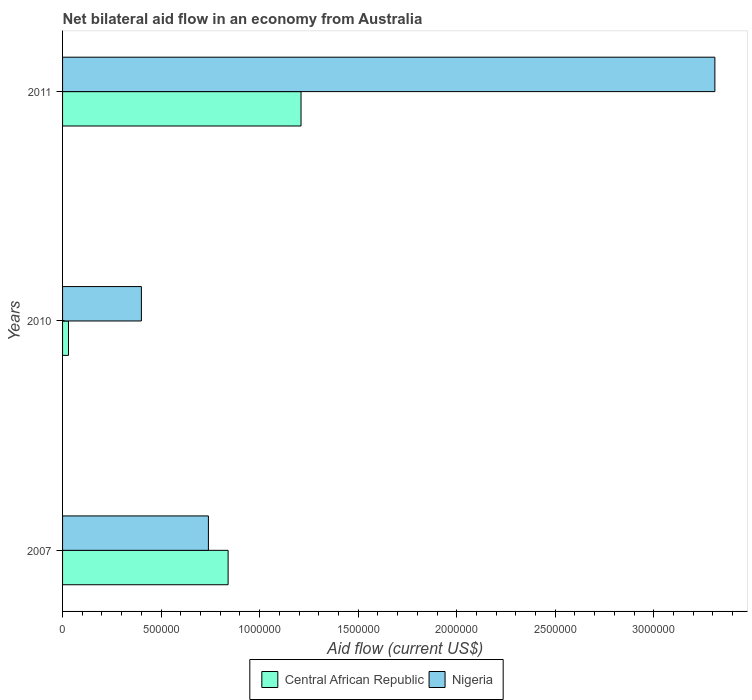How many groups of bars are there?
Your answer should be compact. 3. How many bars are there on the 1st tick from the top?
Offer a very short reply. 2. In how many cases, is the number of bars for a given year not equal to the number of legend labels?
Your answer should be very brief. 0. What is the net bilateral aid flow in Central African Republic in 2011?
Ensure brevity in your answer.  1.21e+06. Across all years, what is the maximum net bilateral aid flow in Nigeria?
Provide a succinct answer. 3.31e+06. Across all years, what is the minimum net bilateral aid flow in Nigeria?
Your answer should be very brief. 4.00e+05. What is the total net bilateral aid flow in Central African Republic in the graph?
Offer a terse response. 2.08e+06. What is the difference between the net bilateral aid flow in Central African Republic in 2007 and that in 2010?
Provide a succinct answer. 8.10e+05. What is the difference between the net bilateral aid flow in Central African Republic in 2010 and the net bilateral aid flow in Nigeria in 2011?
Provide a short and direct response. -3.28e+06. What is the average net bilateral aid flow in Nigeria per year?
Keep it short and to the point. 1.48e+06. In the year 2011, what is the difference between the net bilateral aid flow in Nigeria and net bilateral aid flow in Central African Republic?
Provide a short and direct response. 2.10e+06. In how many years, is the net bilateral aid flow in Central African Republic greater than 2700000 US$?
Ensure brevity in your answer.  0. What is the ratio of the net bilateral aid flow in Nigeria in 2010 to that in 2011?
Your response must be concise. 0.12. Is the net bilateral aid flow in Central African Republic in 2010 less than that in 2011?
Give a very brief answer. Yes. What is the difference between the highest and the second highest net bilateral aid flow in Central African Republic?
Your answer should be very brief. 3.70e+05. What is the difference between the highest and the lowest net bilateral aid flow in Central African Republic?
Provide a succinct answer. 1.18e+06. Is the sum of the net bilateral aid flow in Nigeria in 2010 and 2011 greater than the maximum net bilateral aid flow in Central African Republic across all years?
Provide a short and direct response. Yes. What does the 1st bar from the top in 2007 represents?
Offer a very short reply. Nigeria. What does the 1st bar from the bottom in 2011 represents?
Offer a very short reply. Central African Republic. Are all the bars in the graph horizontal?
Ensure brevity in your answer.  Yes. What is the difference between two consecutive major ticks on the X-axis?
Your answer should be compact. 5.00e+05. Does the graph contain any zero values?
Provide a short and direct response. No. Does the graph contain grids?
Your response must be concise. No. How are the legend labels stacked?
Offer a terse response. Horizontal. What is the title of the graph?
Your response must be concise. Net bilateral aid flow in an economy from Australia. What is the Aid flow (current US$) of Central African Republic in 2007?
Offer a terse response. 8.40e+05. What is the Aid flow (current US$) in Nigeria in 2007?
Ensure brevity in your answer.  7.40e+05. What is the Aid flow (current US$) of Nigeria in 2010?
Your response must be concise. 4.00e+05. What is the Aid flow (current US$) in Central African Republic in 2011?
Offer a very short reply. 1.21e+06. What is the Aid flow (current US$) in Nigeria in 2011?
Make the answer very short. 3.31e+06. Across all years, what is the maximum Aid flow (current US$) of Central African Republic?
Your answer should be very brief. 1.21e+06. Across all years, what is the maximum Aid flow (current US$) of Nigeria?
Provide a short and direct response. 3.31e+06. Across all years, what is the minimum Aid flow (current US$) in Central African Republic?
Your response must be concise. 3.00e+04. What is the total Aid flow (current US$) in Central African Republic in the graph?
Give a very brief answer. 2.08e+06. What is the total Aid flow (current US$) in Nigeria in the graph?
Provide a succinct answer. 4.45e+06. What is the difference between the Aid flow (current US$) of Central African Republic in 2007 and that in 2010?
Provide a short and direct response. 8.10e+05. What is the difference between the Aid flow (current US$) of Central African Republic in 2007 and that in 2011?
Provide a succinct answer. -3.70e+05. What is the difference between the Aid flow (current US$) of Nigeria in 2007 and that in 2011?
Provide a short and direct response. -2.57e+06. What is the difference between the Aid flow (current US$) in Central African Republic in 2010 and that in 2011?
Your answer should be very brief. -1.18e+06. What is the difference between the Aid flow (current US$) in Nigeria in 2010 and that in 2011?
Your answer should be compact. -2.91e+06. What is the difference between the Aid flow (current US$) of Central African Republic in 2007 and the Aid flow (current US$) of Nigeria in 2011?
Make the answer very short. -2.47e+06. What is the difference between the Aid flow (current US$) of Central African Republic in 2010 and the Aid flow (current US$) of Nigeria in 2011?
Offer a very short reply. -3.28e+06. What is the average Aid flow (current US$) in Central African Republic per year?
Offer a terse response. 6.93e+05. What is the average Aid flow (current US$) of Nigeria per year?
Offer a terse response. 1.48e+06. In the year 2007, what is the difference between the Aid flow (current US$) of Central African Republic and Aid flow (current US$) of Nigeria?
Make the answer very short. 1.00e+05. In the year 2010, what is the difference between the Aid flow (current US$) in Central African Republic and Aid flow (current US$) in Nigeria?
Keep it short and to the point. -3.70e+05. In the year 2011, what is the difference between the Aid flow (current US$) of Central African Republic and Aid flow (current US$) of Nigeria?
Keep it short and to the point. -2.10e+06. What is the ratio of the Aid flow (current US$) in Nigeria in 2007 to that in 2010?
Give a very brief answer. 1.85. What is the ratio of the Aid flow (current US$) of Central African Republic in 2007 to that in 2011?
Your answer should be very brief. 0.69. What is the ratio of the Aid flow (current US$) of Nigeria in 2007 to that in 2011?
Make the answer very short. 0.22. What is the ratio of the Aid flow (current US$) in Central African Republic in 2010 to that in 2011?
Offer a terse response. 0.02. What is the ratio of the Aid flow (current US$) of Nigeria in 2010 to that in 2011?
Your answer should be compact. 0.12. What is the difference between the highest and the second highest Aid flow (current US$) in Nigeria?
Ensure brevity in your answer.  2.57e+06. What is the difference between the highest and the lowest Aid flow (current US$) in Central African Republic?
Offer a terse response. 1.18e+06. What is the difference between the highest and the lowest Aid flow (current US$) of Nigeria?
Keep it short and to the point. 2.91e+06. 